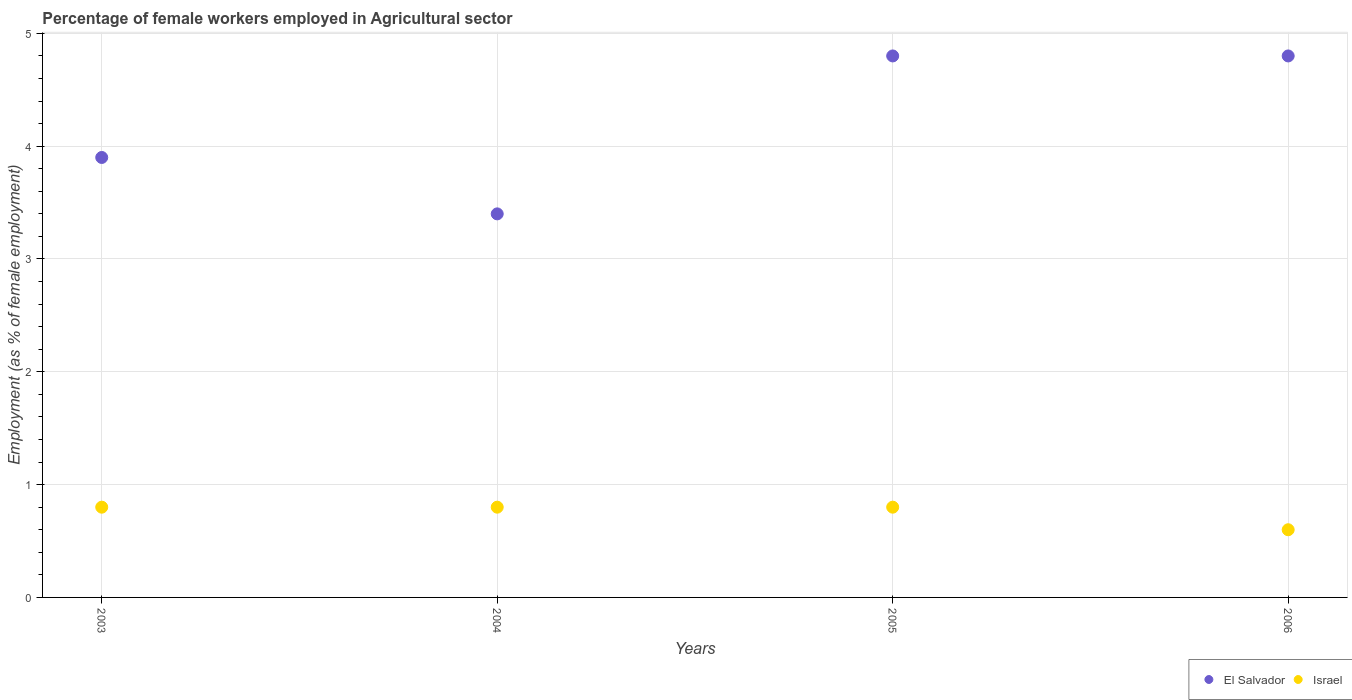Is the number of dotlines equal to the number of legend labels?
Your response must be concise. Yes. What is the percentage of females employed in Agricultural sector in Israel in 2006?
Offer a terse response. 0.6. Across all years, what is the maximum percentage of females employed in Agricultural sector in El Salvador?
Give a very brief answer. 4.8. Across all years, what is the minimum percentage of females employed in Agricultural sector in El Salvador?
Your answer should be very brief. 3.4. In which year was the percentage of females employed in Agricultural sector in El Salvador maximum?
Keep it short and to the point. 2005. In which year was the percentage of females employed in Agricultural sector in El Salvador minimum?
Keep it short and to the point. 2004. What is the total percentage of females employed in Agricultural sector in El Salvador in the graph?
Offer a terse response. 16.9. What is the difference between the percentage of females employed in Agricultural sector in El Salvador in 2005 and that in 2006?
Ensure brevity in your answer.  0. What is the difference between the percentage of females employed in Agricultural sector in Israel in 2006 and the percentage of females employed in Agricultural sector in El Salvador in 2005?
Keep it short and to the point. -4.2. What is the average percentage of females employed in Agricultural sector in Israel per year?
Ensure brevity in your answer.  0.75. In the year 2005, what is the difference between the percentage of females employed in Agricultural sector in El Salvador and percentage of females employed in Agricultural sector in Israel?
Keep it short and to the point. 4. What is the ratio of the percentage of females employed in Agricultural sector in El Salvador in 2003 to that in 2005?
Provide a short and direct response. 0.81. Is the percentage of females employed in Agricultural sector in El Salvador in 2005 less than that in 2006?
Your response must be concise. No. What is the difference between the highest and the second highest percentage of females employed in Agricultural sector in El Salvador?
Your response must be concise. 0. What is the difference between the highest and the lowest percentage of females employed in Agricultural sector in Israel?
Offer a very short reply. 0.2. Is the sum of the percentage of females employed in Agricultural sector in El Salvador in 2005 and 2006 greater than the maximum percentage of females employed in Agricultural sector in Israel across all years?
Ensure brevity in your answer.  Yes. Is the percentage of females employed in Agricultural sector in El Salvador strictly less than the percentage of females employed in Agricultural sector in Israel over the years?
Make the answer very short. No. How many dotlines are there?
Provide a short and direct response. 2. How many years are there in the graph?
Ensure brevity in your answer.  4. Does the graph contain any zero values?
Your answer should be very brief. No. How many legend labels are there?
Offer a very short reply. 2. How are the legend labels stacked?
Give a very brief answer. Horizontal. What is the title of the graph?
Provide a short and direct response. Percentage of female workers employed in Agricultural sector. Does "Peru" appear as one of the legend labels in the graph?
Your response must be concise. No. What is the label or title of the X-axis?
Offer a terse response. Years. What is the label or title of the Y-axis?
Provide a succinct answer. Employment (as % of female employment). What is the Employment (as % of female employment) of El Salvador in 2003?
Give a very brief answer. 3.9. What is the Employment (as % of female employment) of Israel in 2003?
Offer a terse response. 0.8. What is the Employment (as % of female employment) of El Salvador in 2004?
Your response must be concise. 3.4. What is the Employment (as % of female employment) in Israel in 2004?
Offer a terse response. 0.8. What is the Employment (as % of female employment) of El Salvador in 2005?
Give a very brief answer. 4.8. What is the Employment (as % of female employment) in Israel in 2005?
Offer a terse response. 0.8. What is the Employment (as % of female employment) in El Salvador in 2006?
Provide a short and direct response. 4.8. What is the Employment (as % of female employment) of Israel in 2006?
Your answer should be very brief. 0.6. Across all years, what is the maximum Employment (as % of female employment) of El Salvador?
Your response must be concise. 4.8. Across all years, what is the maximum Employment (as % of female employment) in Israel?
Your answer should be very brief. 0.8. Across all years, what is the minimum Employment (as % of female employment) of El Salvador?
Your answer should be very brief. 3.4. Across all years, what is the minimum Employment (as % of female employment) in Israel?
Keep it short and to the point. 0.6. What is the total Employment (as % of female employment) in El Salvador in the graph?
Ensure brevity in your answer.  16.9. What is the total Employment (as % of female employment) of Israel in the graph?
Offer a very short reply. 3. What is the difference between the Employment (as % of female employment) of El Salvador in 2003 and that in 2004?
Offer a terse response. 0.5. What is the difference between the Employment (as % of female employment) of El Salvador in 2003 and that in 2006?
Provide a short and direct response. -0.9. What is the difference between the Employment (as % of female employment) of Israel in 2004 and that in 2005?
Give a very brief answer. 0. What is the difference between the Employment (as % of female employment) of Israel in 2004 and that in 2006?
Ensure brevity in your answer.  0.2. What is the difference between the Employment (as % of female employment) in El Salvador in 2003 and the Employment (as % of female employment) in Israel in 2006?
Keep it short and to the point. 3.3. What is the difference between the Employment (as % of female employment) in El Salvador in 2004 and the Employment (as % of female employment) in Israel in 2005?
Your answer should be compact. 2.6. What is the difference between the Employment (as % of female employment) of El Salvador in 2004 and the Employment (as % of female employment) of Israel in 2006?
Your response must be concise. 2.8. What is the average Employment (as % of female employment) in El Salvador per year?
Give a very brief answer. 4.22. What is the average Employment (as % of female employment) of Israel per year?
Ensure brevity in your answer.  0.75. In the year 2005, what is the difference between the Employment (as % of female employment) of El Salvador and Employment (as % of female employment) of Israel?
Ensure brevity in your answer.  4. In the year 2006, what is the difference between the Employment (as % of female employment) of El Salvador and Employment (as % of female employment) of Israel?
Provide a succinct answer. 4.2. What is the ratio of the Employment (as % of female employment) of El Salvador in 2003 to that in 2004?
Offer a very short reply. 1.15. What is the ratio of the Employment (as % of female employment) of El Salvador in 2003 to that in 2005?
Offer a very short reply. 0.81. What is the ratio of the Employment (as % of female employment) in El Salvador in 2003 to that in 2006?
Offer a terse response. 0.81. What is the ratio of the Employment (as % of female employment) in El Salvador in 2004 to that in 2005?
Keep it short and to the point. 0.71. What is the ratio of the Employment (as % of female employment) of Israel in 2004 to that in 2005?
Ensure brevity in your answer.  1. What is the ratio of the Employment (as % of female employment) in El Salvador in 2004 to that in 2006?
Give a very brief answer. 0.71. What is the difference between the highest and the second highest Employment (as % of female employment) of El Salvador?
Keep it short and to the point. 0. What is the difference between the highest and the lowest Employment (as % of female employment) in El Salvador?
Provide a succinct answer. 1.4. 